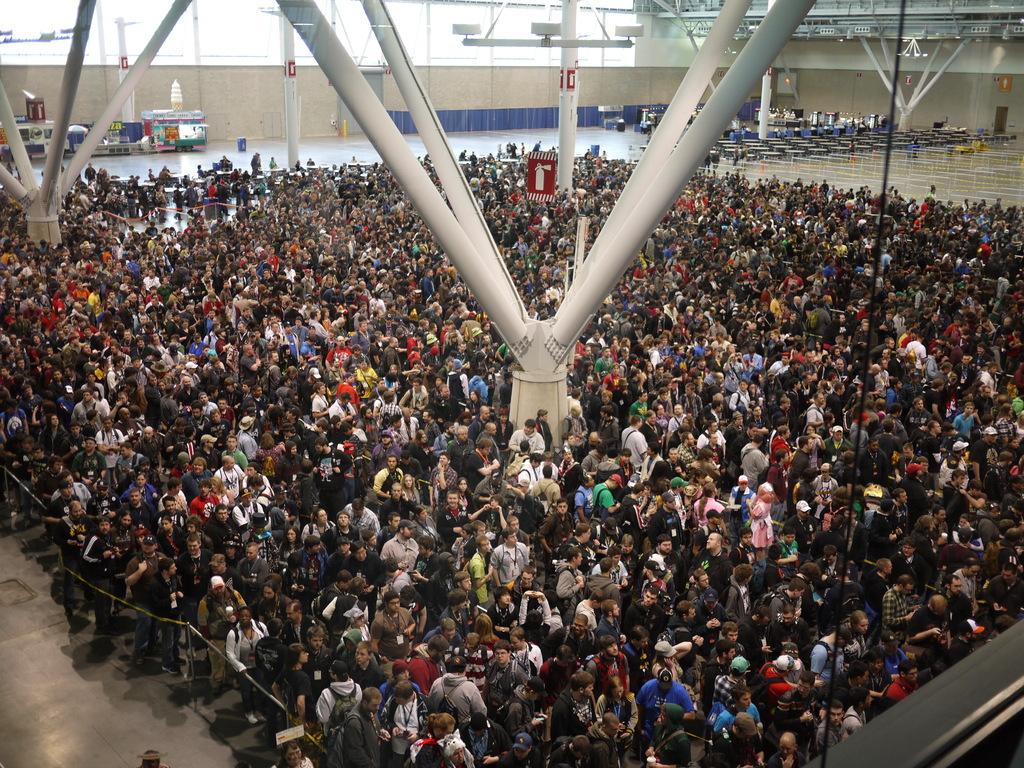Who or what can be seen in the image? There are people in the image. What is the surface beneath the people? There is a floor visible in the image. What structures are present in the image? There are poles in the image. What can be seen in the distance in the image? There is a wall in the background of the image, and there are objects visible in the background as well. What type of marble is being used to decorate the gate in the image? There is no gate present in the image, and therefore no marble can be observed. What type of school can be seen in the background of the image? There is no school visible in the image; only a wall and objects can be seen in the background. 